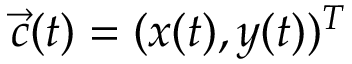<formula> <loc_0><loc_0><loc_500><loc_500>{ \vec { c } } ( t ) = ( x ( t ) , y ( t ) ) ^ { T }</formula> 